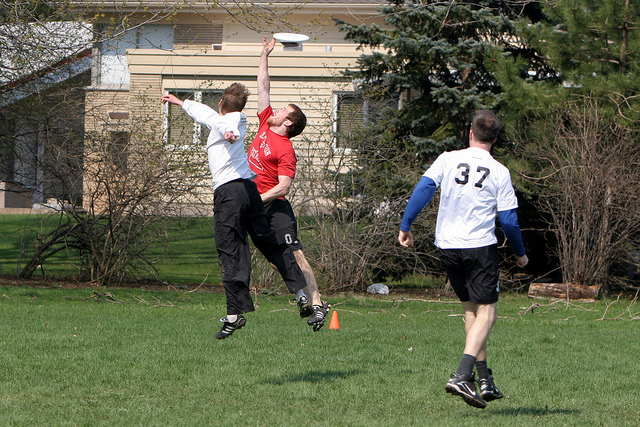Please transcribe the text information in this image. 0 37 